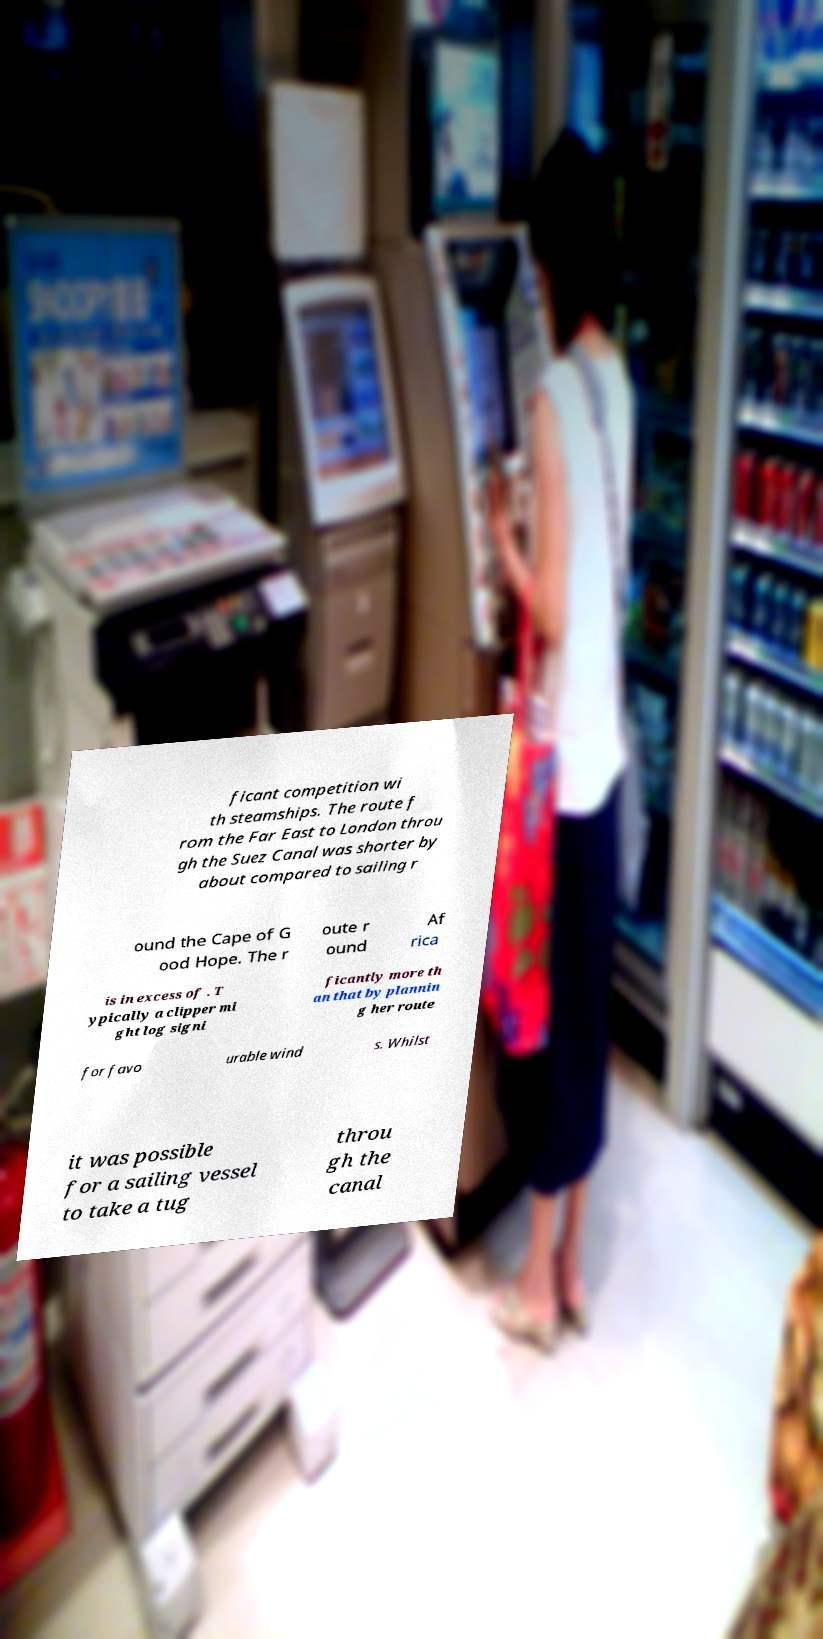Could you assist in decoding the text presented in this image and type it out clearly? ficant competition wi th steamships. The route f rom the Far East to London throu gh the Suez Canal was shorter by about compared to sailing r ound the Cape of G ood Hope. The r oute r ound Af rica is in excess of . T ypically a clipper mi ght log signi ficantly more th an that by plannin g her route for favo urable wind s. Whilst it was possible for a sailing vessel to take a tug throu gh the canal 